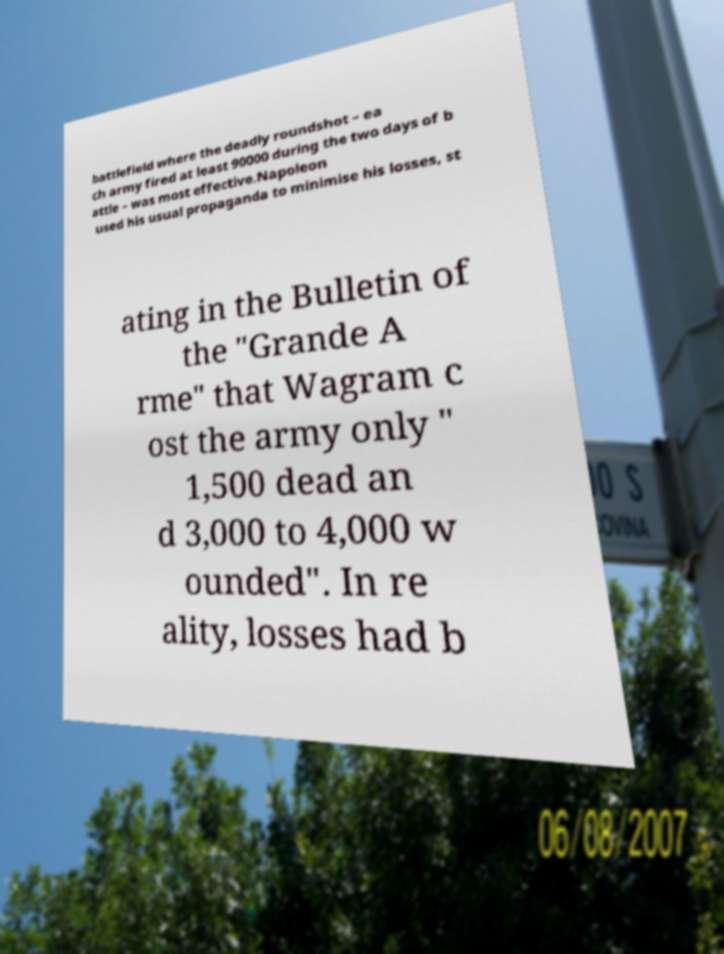I need the written content from this picture converted into text. Can you do that? battlefield where the deadly roundshot – ea ch army fired at least 90000 during the two days of b attle – was most effective.Napoleon used his usual propaganda to minimise his losses, st ating in the Bulletin of the "Grande A rme" that Wagram c ost the army only " 1,500 dead an d 3,000 to 4,000 w ounded". In re ality, losses had b 